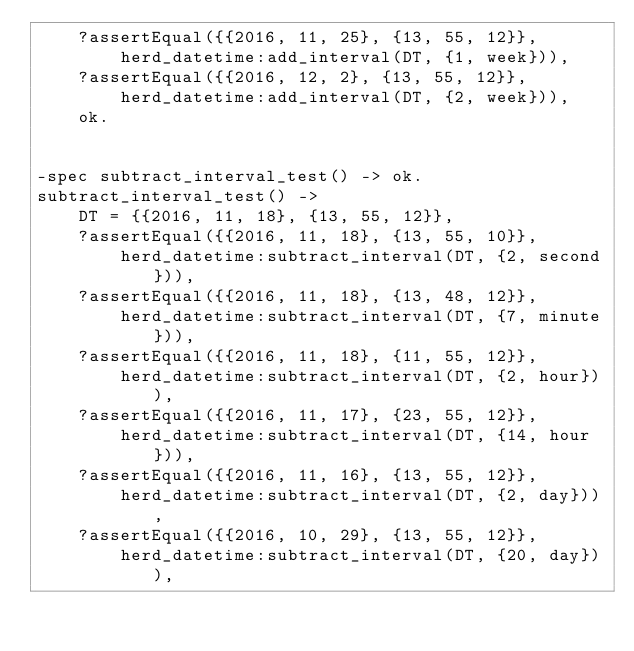<code> <loc_0><loc_0><loc_500><loc_500><_Erlang_>    ?assertEqual({{2016, 11, 25}, {13, 55, 12}},
        herd_datetime:add_interval(DT, {1, week})),
    ?assertEqual({{2016, 12, 2}, {13, 55, 12}},
        herd_datetime:add_interval(DT, {2, week})),
    ok.


-spec subtract_interval_test() -> ok.
subtract_interval_test() ->
    DT = {{2016, 11, 18}, {13, 55, 12}},
    ?assertEqual({{2016, 11, 18}, {13, 55, 10}},
        herd_datetime:subtract_interval(DT, {2, second})),
    ?assertEqual({{2016, 11, 18}, {13, 48, 12}},
        herd_datetime:subtract_interval(DT, {7, minute})),
    ?assertEqual({{2016, 11, 18}, {11, 55, 12}},
        herd_datetime:subtract_interval(DT, {2, hour})),
    ?assertEqual({{2016, 11, 17}, {23, 55, 12}},
        herd_datetime:subtract_interval(DT, {14, hour})),
    ?assertEqual({{2016, 11, 16}, {13, 55, 12}},
        herd_datetime:subtract_interval(DT, {2, day})),
    ?assertEqual({{2016, 10, 29}, {13, 55, 12}},
        herd_datetime:subtract_interval(DT, {20, day})),</code> 